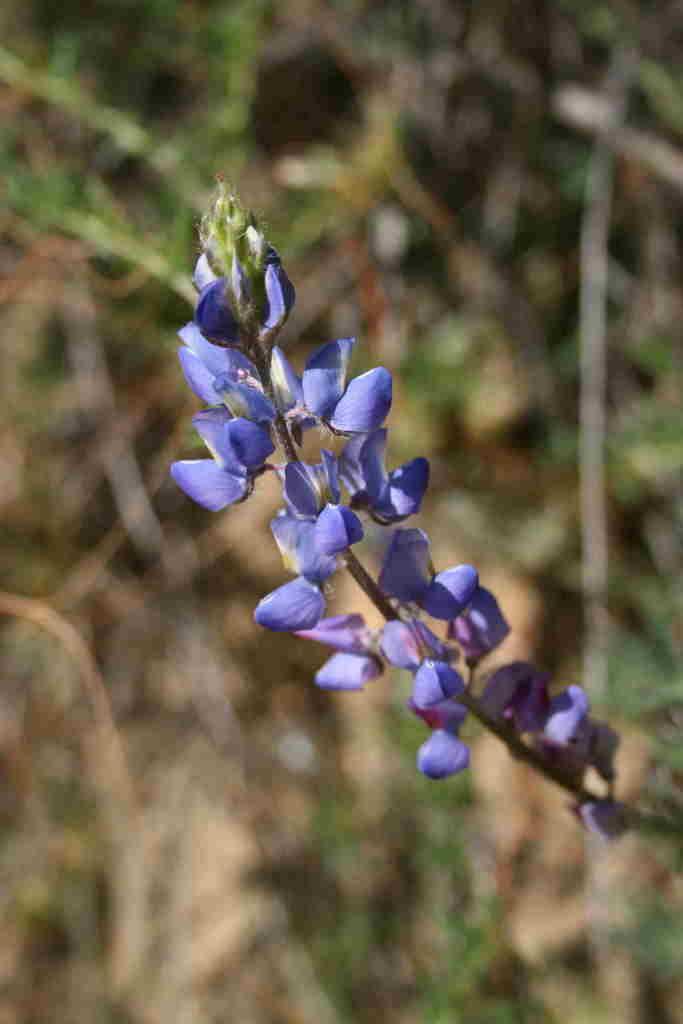How would you summarize this image in a sentence or two? In this picture we can observe violet color flowers to the plant. In the background we can observe some plants which are blurred. 